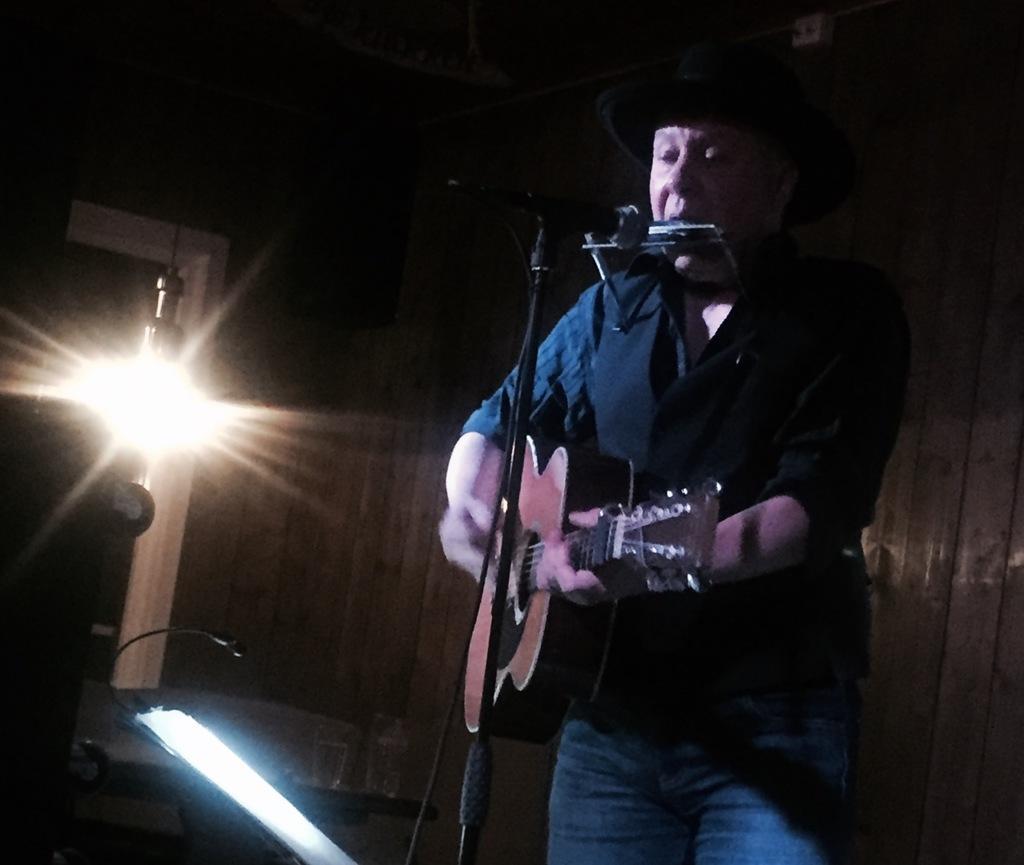Please provide a concise description of this image. In this image, human is playing a musical instrument in-front of microphone. He is singing, he wear a cap on his head. Left side, we can see light, microphone, light , tables. And back side, we can see wooden wall. 